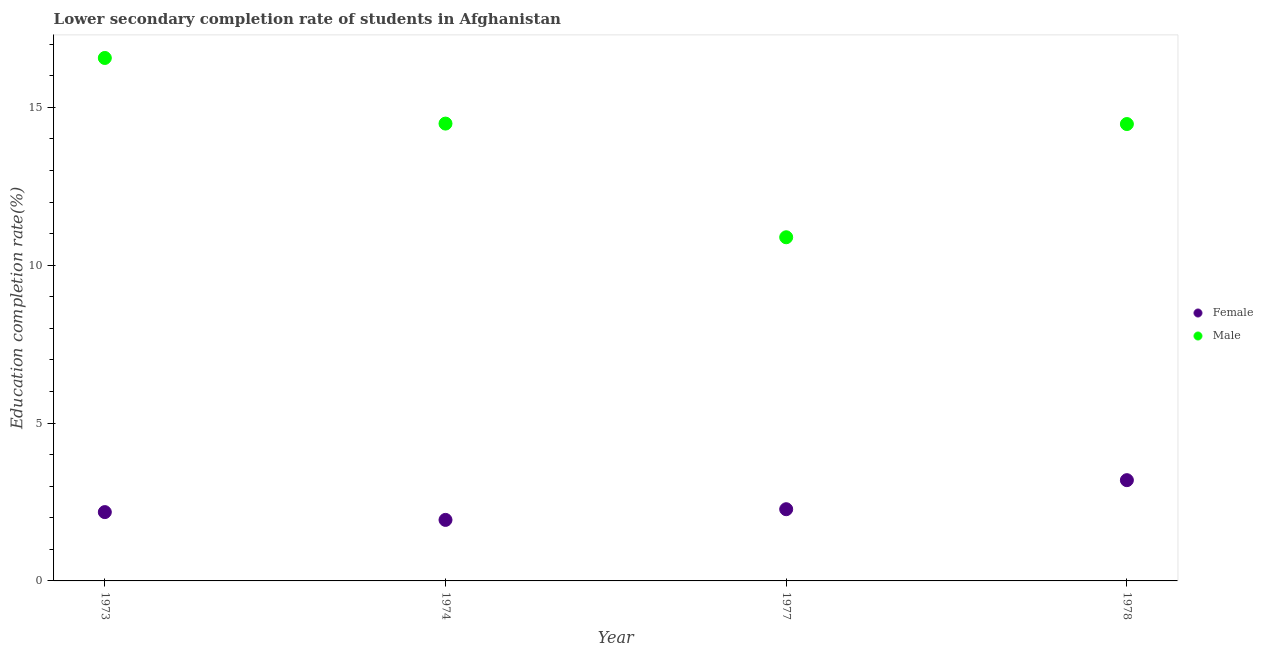How many different coloured dotlines are there?
Keep it short and to the point. 2. Is the number of dotlines equal to the number of legend labels?
Offer a very short reply. Yes. What is the education completion rate of female students in 1974?
Ensure brevity in your answer.  1.93. Across all years, what is the maximum education completion rate of male students?
Ensure brevity in your answer.  16.57. Across all years, what is the minimum education completion rate of male students?
Your response must be concise. 10.89. In which year was the education completion rate of female students maximum?
Offer a very short reply. 1978. In which year was the education completion rate of male students minimum?
Ensure brevity in your answer.  1977. What is the total education completion rate of female students in the graph?
Provide a short and direct response. 9.58. What is the difference between the education completion rate of male students in 1974 and that in 1977?
Make the answer very short. 3.6. What is the difference between the education completion rate of male students in 1977 and the education completion rate of female students in 1973?
Make the answer very short. 8.71. What is the average education completion rate of male students per year?
Your answer should be compact. 14.1. In the year 1978, what is the difference between the education completion rate of female students and education completion rate of male students?
Ensure brevity in your answer.  -11.28. In how many years, is the education completion rate of male students greater than 3 %?
Keep it short and to the point. 4. What is the ratio of the education completion rate of male students in 1974 to that in 1978?
Provide a short and direct response. 1. Is the education completion rate of male students in 1974 less than that in 1978?
Provide a succinct answer. No. What is the difference between the highest and the second highest education completion rate of female students?
Provide a succinct answer. 0.92. What is the difference between the highest and the lowest education completion rate of female students?
Your answer should be compact. 1.26. Does the education completion rate of female students monotonically increase over the years?
Your answer should be very brief. No. Is the education completion rate of female students strictly greater than the education completion rate of male students over the years?
Provide a short and direct response. No. Is the education completion rate of male students strictly less than the education completion rate of female students over the years?
Offer a very short reply. No. Does the graph contain grids?
Provide a short and direct response. No. Where does the legend appear in the graph?
Offer a terse response. Center right. How many legend labels are there?
Your response must be concise. 2. How are the legend labels stacked?
Provide a succinct answer. Vertical. What is the title of the graph?
Ensure brevity in your answer.  Lower secondary completion rate of students in Afghanistan. Does "Underweight" appear as one of the legend labels in the graph?
Keep it short and to the point. No. What is the label or title of the Y-axis?
Offer a very short reply. Education completion rate(%). What is the Education completion rate(%) in Female in 1973?
Your answer should be compact. 2.18. What is the Education completion rate(%) in Male in 1973?
Give a very brief answer. 16.57. What is the Education completion rate(%) of Female in 1974?
Offer a terse response. 1.93. What is the Education completion rate(%) of Male in 1974?
Offer a very short reply. 14.49. What is the Education completion rate(%) of Female in 1977?
Your response must be concise. 2.27. What is the Education completion rate(%) in Male in 1977?
Make the answer very short. 10.89. What is the Education completion rate(%) of Female in 1978?
Offer a terse response. 3.19. What is the Education completion rate(%) of Male in 1978?
Provide a succinct answer. 14.47. Across all years, what is the maximum Education completion rate(%) of Female?
Your response must be concise. 3.19. Across all years, what is the maximum Education completion rate(%) in Male?
Offer a very short reply. 16.57. Across all years, what is the minimum Education completion rate(%) of Female?
Your answer should be compact. 1.93. Across all years, what is the minimum Education completion rate(%) of Male?
Keep it short and to the point. 10.89. What is the total Education completion rate(%) in Female in the graph?
Offer a very short reply. 9.58. What is the total Education completion rate(%) of Male in the graph?
Offer a terse response. 56.41. What is the difference between the Education completion rate(%) in Female in 1973 and that in 1974?
Your response must be concise. 0.25. What is the difference between the Education completion rate(%) of Male in 1973 and that in 1974?
Your answer should be compact. 2.08. What is the difference between the Education completion rate(%) of Female in 1973 and that in 1977?
Make the answer very short. -0.09. What is the difference between the Education completion rate(%) in Male in 1973 and that in 1977?
Your response must be concise. 5.68. What is the difference between the Education completion rate(%) in Female in 1973 and that in 1978?
Keep it short and to the point. -1.01. What is the difference between the Education completion rate(%) of Male in 1973 and that in 1978?
Make the answer very short. 2.09. What is the difference between the Education completion rate(%) of Female in 1974 and that in 1977?
Provide a succinct answer. -0.34. What is the difference between the Education completion rate(%) in Male in 1974 and that in 1977?
Provide a short and direct response. 3.6. What is the difference between the Education completion rate(%) of Female in 1974 and that in 1978?
Make the answer very short. -1.26. What is the difference between the Education completion rate(%) of Male in 1974 and that in 1978?
Ensure brevity in your answer.  0.01. What is the difference between the Education completion rate(%) in Female in 1977 and that in 1978?
Your answer should be very brief. -0.92. What is the difference between the Education completion rate(%) in Male in 1977 and that in 1978?
Provide a short and direct response. -3.59. What is the difference between the Education completion rate(%) in Female in 1973 and the Education completion rate(%) in Male in 1974?
Provide a short and direct response. -12.31. What is the difference between the Education completion rate(%) in Female in 1973 and the Education completion rate(%) in Male in 1977?
Offer a terse response. -8.71. What is the difference between the Education completion rate(%) of Female in 1973 and the Education completion rate(%) of Male in 1978?
Ensure brevity in your answer.  -12.29. What is the difference between the Education completion rate(%) in Female in 1974 and the Education completion rate(%) in Male in 1977?
Your answer should be very brief. -8.95. What is the difference between the Education completion rate(%) of Female in 1974 and the Education completion rate(%) of Male in 1978?
Give a very brief answer. -12.54. What is the difference between the Education completion rate(%) of Female in 1977 and the Education completion rate(%) of Male in 1978?
Ensure brevity in your answer.  -12.2. What is the average Education completion rate(%) in Female per year?
Give a very brief answer. 2.39. What is the average Education completion rate(%) in Male per year?
Your response must be concise. 14.1. In the year 1973, what is the difference between the Education completion rate(%) in Female and Education completion rate(%) in Male?
Keep it short and to the point. -14.39. In the year 1974, what is the difference between the Education completion rate(%) in Female and Education completion rate(%) in Male?
Provide a succinct answer. -12.55. In the year 1977, what is the difference between the Education completion rate(%) in Female and Education completion rate(%) in Male?
Your answer should be compact. -8.62. In the year 1978, what is the difference between the Education completion rate(%) of Female and Education completion rate(%) of Male?
Provide a short and direct response. -11.28. What is the ratio of the Education completion rate(%) of Female in 1973 to that in 1974?
Your response must be concise. 1.13. What is the ratio of the Education completion rate(%) of Male in 1973 to that in 1974?
Provide a succinct answer. 1.14. What is the ratio of the Education completion rate(%) in Female in 1973 to that in 1977?
Ensure brevity in your answer.  0.96. What is the ratio of the Education completion rate(%) of Male in 1973 to that in 1977?
Offer a terse response. 1.52. What is the ratio of the Education completion rate(%) of Female in 1973 to that in 1978?
Ensure brevity in your answer.  0.68. What is the ratio of the Education completion rate(%) in Male in 1973 to that in 1978?
Your response must be concise. 1.14. What is the ratio of the Education completion rate(%) in Female in 1974 to that in 1977?
Provide a succinct answer. 0.85. What is the ratio of the Education completion rate(%) of Male in 1974 to that in 1977?
Make the answer very short. 1.33. What is the ratio of the Education completion rate(%) of Female in 1974 to that in 1978?
Keep it short and to the point. 0.61. What is the ratio of the Education completion rate(%) of Male in 1974 to that in 1978?
Offer a terse response. 1. What is the ratio of the Education completion rate(%) of Female in 1977 to that in 1978?
Your answer should be very brief. 0.71. What is the ratio of the Education completion rate(%) of Male in 1977 to that in 1978?
Offer a terse response. 0.75. What is the difference between the highest and the second highest Education completion rate(%) of Female?
Your answer should be compact. 0.92. What is the difference between the highest and the second highest Education completion rate(%) in Male?
Your answer should be very brief. 2.08. What is the difference between the highest and the lowest Education completion rate(%) in Female?
Provide a succinct answer. 1.26. What is the difference between the highest and the lowest Education completion rate(%) in Male?
Your response must be concise. 5.68. 